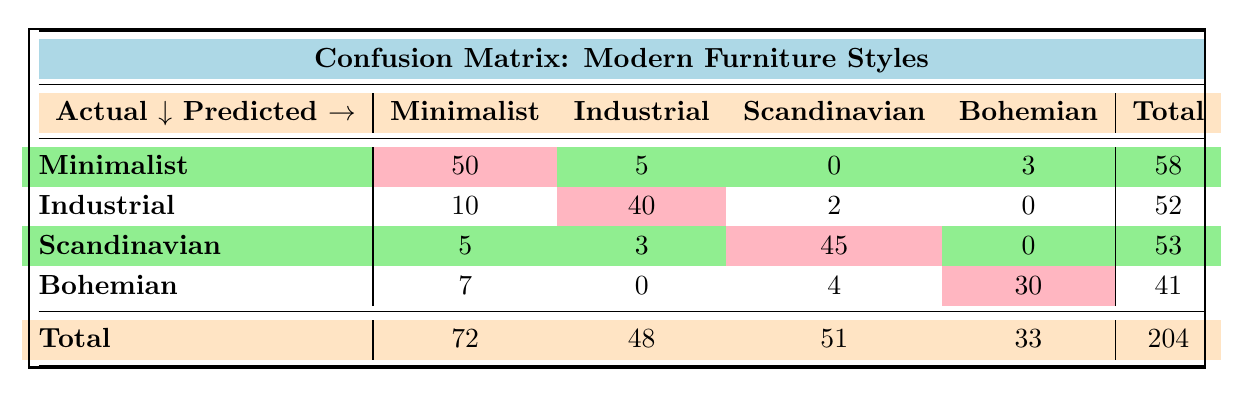What is the total number of customers who preferred Scandinavian furniture? To find the total customers who preferred Scandinavian furniture, we look at the total column under the Scandinavian row. The total is 53, indicating that 53 customers preferred Scandinavian furniture.
Answer: 53 How many customers predicted Minimalist style but chose Industrial? The count of customers who predicted Minimalist style but chose Industrial is found in the row for Minimalist and the column for Industrial, which is 5.
Answer: 5 What is the average number of customers who correctly identified their style across all categories? To find the average number of customers who correctly identified their style, we sum the diagonal values (50 for Minimalist, 40 for Industrial, 45 for Scandinavian, and 30 for Bohemian), resulting in a total of 165. Then, we divide by the number of categories (4): 165/4 = 41.25.
Answer: 41.25 Is it true that more customers preferred Bohemian style than Scandinavian style? We compare the total number of customers for Bohemian (41) against Scandinavian (53). Since 41 is less than 53, the statement is false.
Answer: No What is the difference between the total number of customers who predicted Scandinavian style and those who predicted Industrial style? We look at the total number of customers who predicted Scandinavian style (51) and Industrial style (48). To find the difference, we subtract: 51 - 48 = 3.
Answer: 3 How many customers predicted Bohemian but actually preferred Minimalist or Scandinavian? To find the total customers who predicted Bohemian but preferred Minimalist or Scandinavian, we sum the values in the Bohemian row under Minimalist (7) and Scandinavian (4) columns: 7 + 4 = 11.
Answer: 11 Which style had the highest total number of customers? We need to compare the total values for each style: Minimalist (72), Industrial (48), Scandinavian (51), and Bohemian (33). The highest total is for Minimalist with 72.
Answer: Minimalist How many customers incorrectly predicted Industrial style? To find the total customers who incorrectly predicted Industrial style, we sum all counts in the Industrial row except the correct prediction (40): 10 (Minimalist) + 2 (Scandinavian) + 0 (Bohemian) = 12.
Answer: 12 